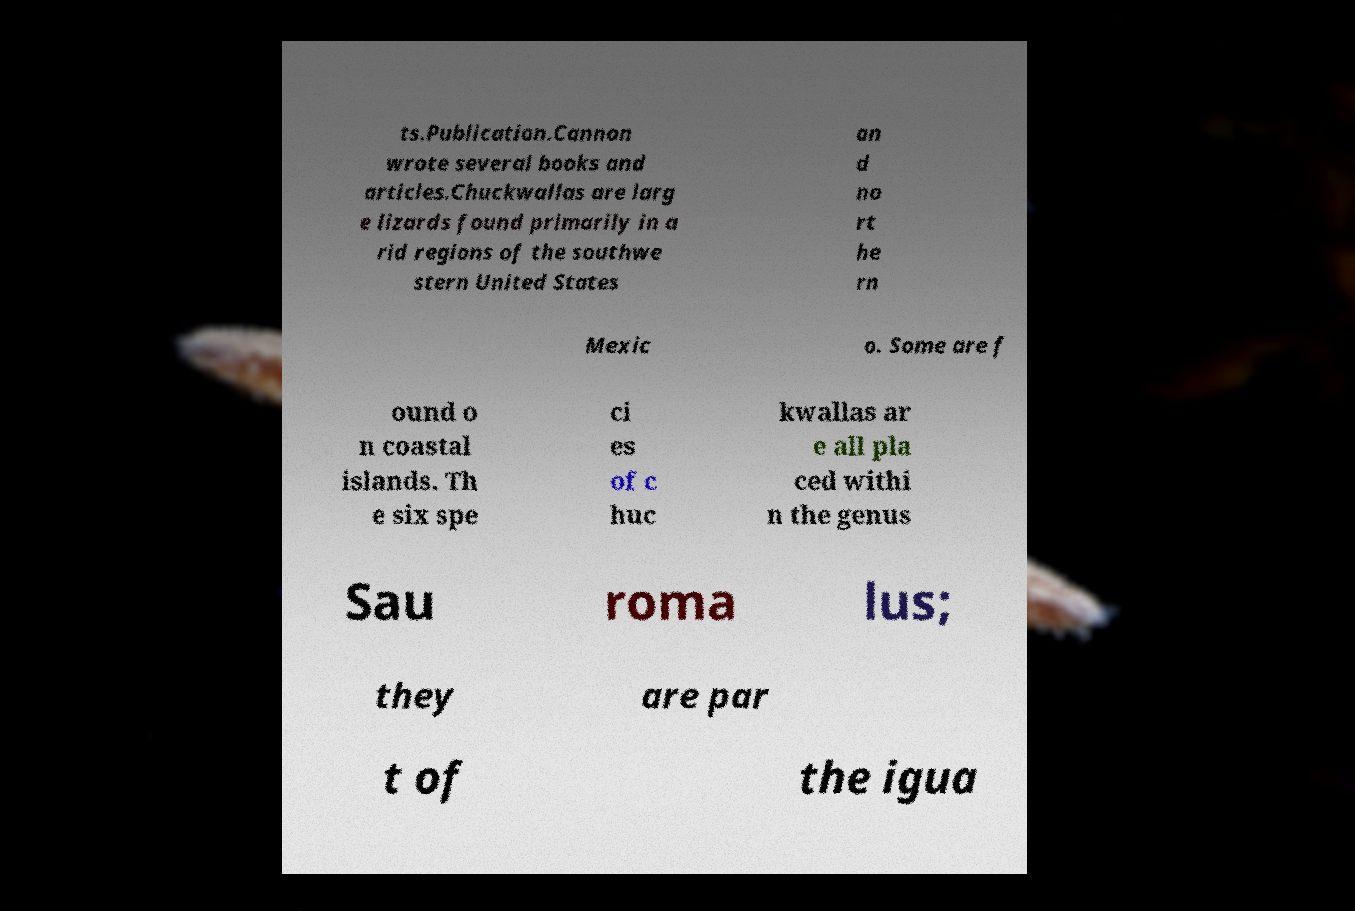There's text embedded in this image that I need extracted. Can you transcribe it verbatim? ts.Publication.Cannon wrote several books and articles.Chuckwallas are larg e lizards found primarily in a rid regions of the southwe stern United States an d no rt he rn Mexic o. Some are f ound o n coastal islands. Th e six spe ci es of c huc kwallas ar e all pla ced withi n the genus Sau roma lus; they are par t of the igua 